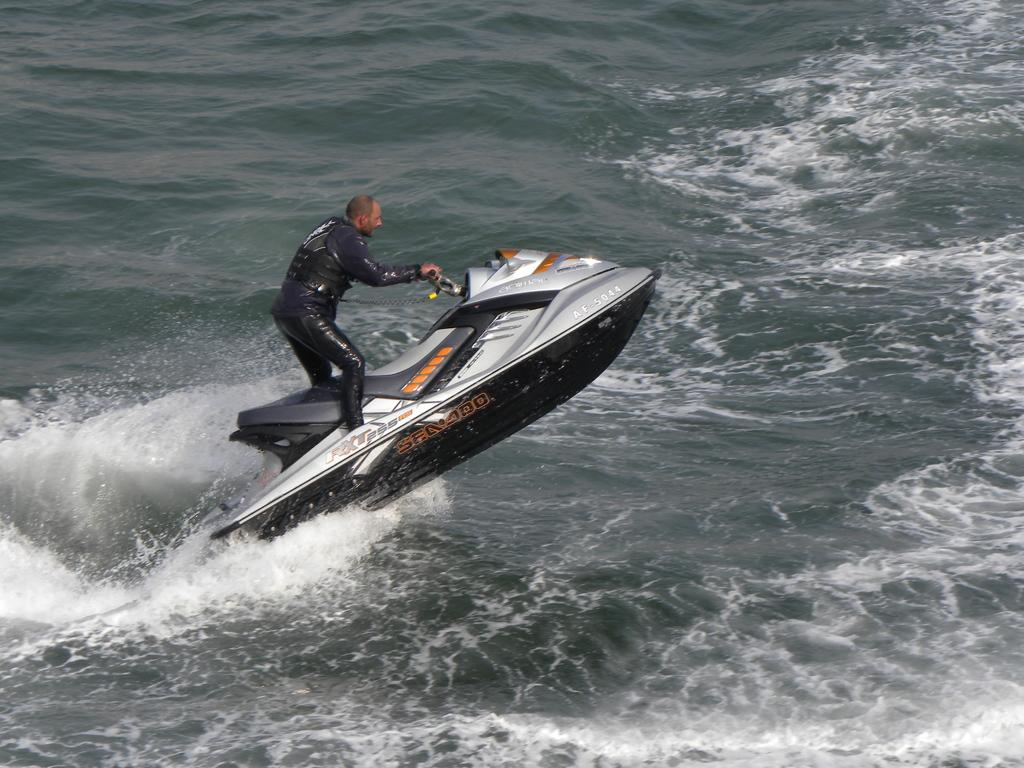What is the main subject of the image? There is a man in the image. What is the man doing in the image? The man is riding a jet ski. Where is the jet ski located? The jet ski is on the water. How many shelves can be seen in the image? There are no shelves present in the image. What type of kick is the man performing on the jet ski? There is no kick being performed in the image; the man is simply riding the jet ski. 